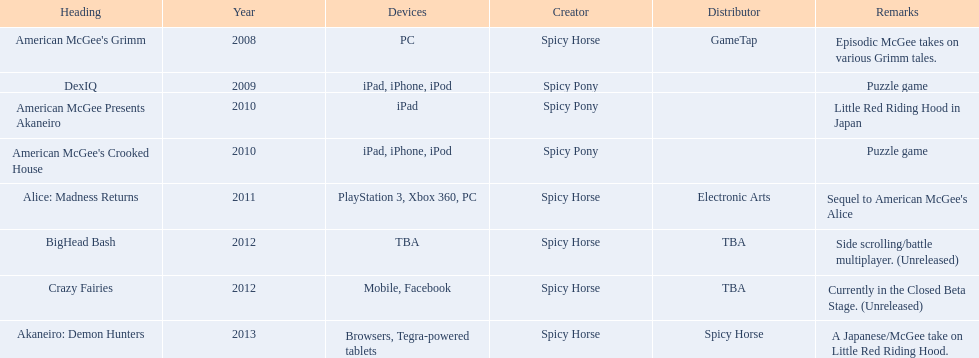What spicy horse titles are listed? American McGee's Grimm, DexIQ, American McGee Presents Akaneiro, American McGee's Crooked House, Alice: Madness Returns, BigHead Bash, Crazy Fairies, Akaneiro: Demon Hunters. Which of these can be used on ipad? DexIQ, American McGee Presents Akaneiro, American McGee's Crooked House. Which left cannot also be used on iphone or ipod? American McGee Presents Akaneiro. 